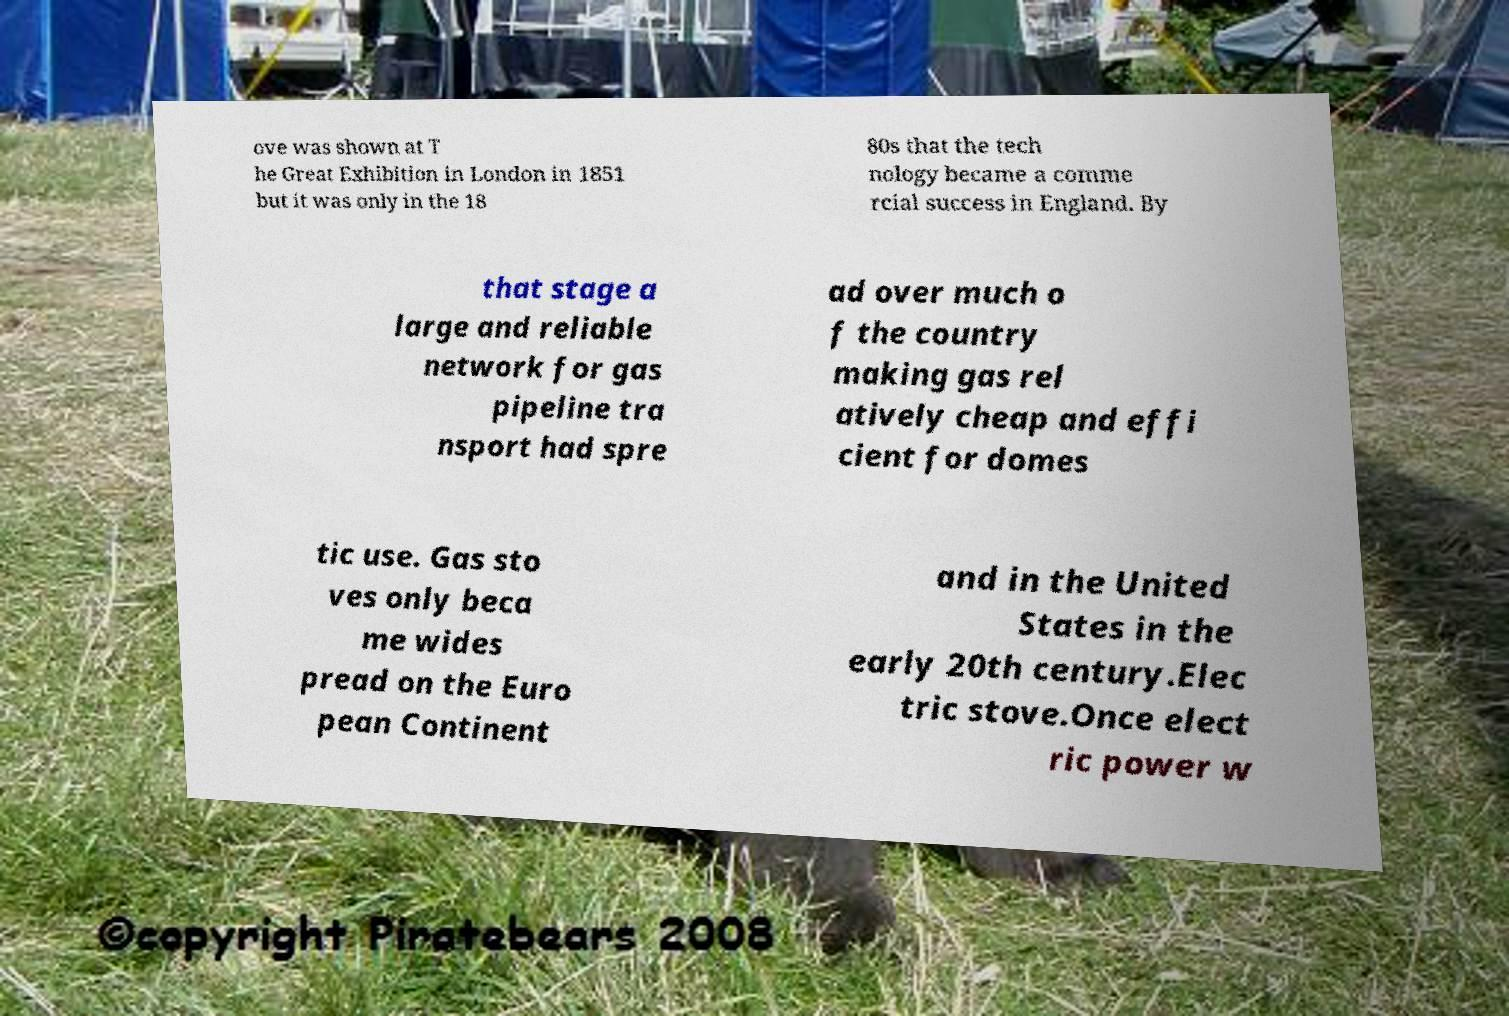Please identify and transcribe the text found in this image. ove was shown at T he Great Exhibition in London in 1851 but it was only in the 18 80s that the tech nology became a comme rcial success in England. By that stage a large and reliable network for gas pipeline tra nsport had spre ad over much o f the country making gas rel atively cheap and effi cient for domes tic use. Gas sto ves only beca me wides pread on the Euro pean Continent and in the United States in the early 20th century.Elec tric stove.Once elect ric power w 